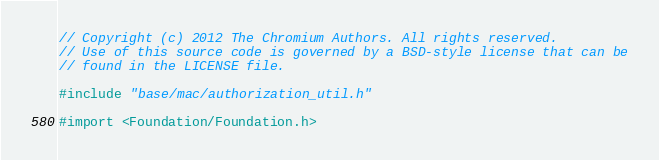Convert code to text. <code><loc_0><loc_0><loc_500><loc_500><_ObjectiveC_>// Copyright (c) 2012 The Chromium Authors. All rights reserved.
// Use of this source code is governed by a BSD-style license that can be
// found in the LICENSE file.

#include "base/mac/authorization_util.h"

#import <Foundation/Foundation.h></code> 